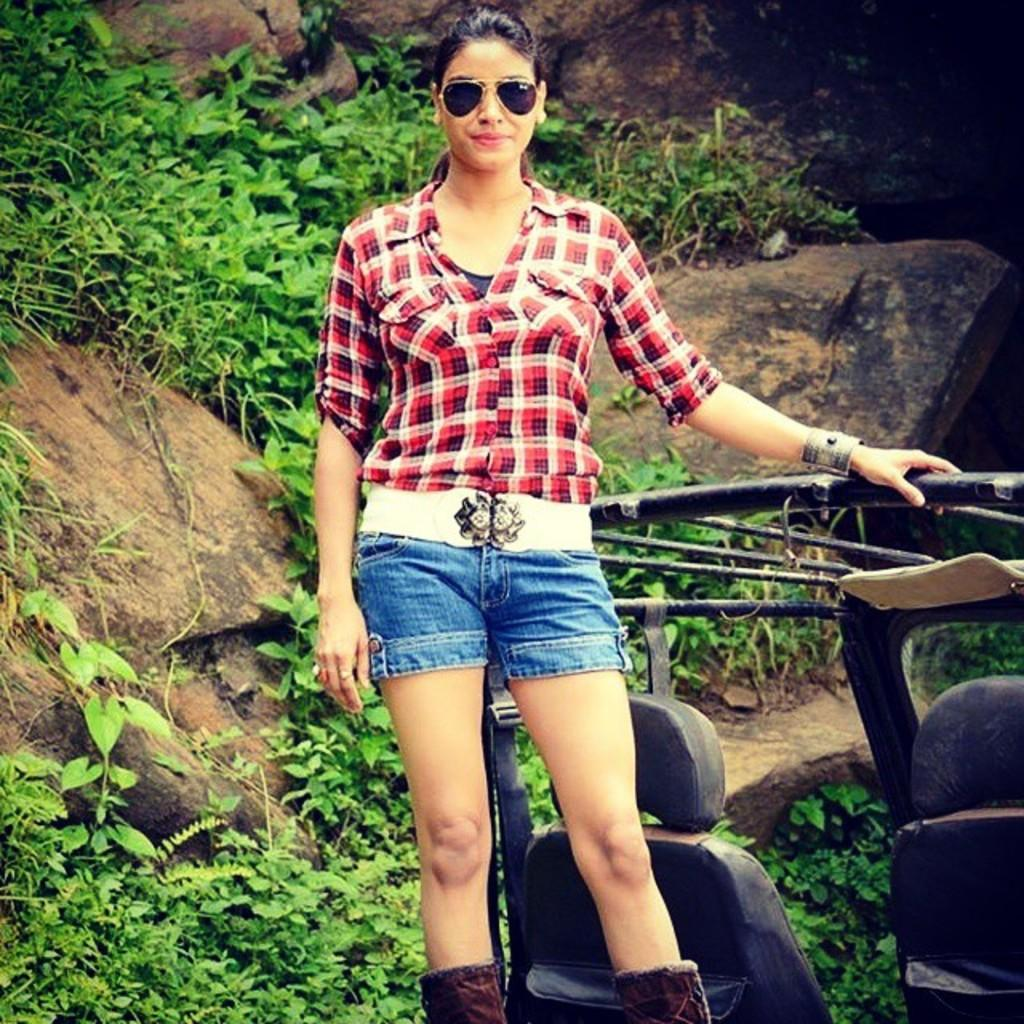Who is present in the image? There is a woman in the image. What is the woman doing in the image? The woman is standing on a vehicle. What protective gear is the woman wearing? The woman is wearing goggles. What clothing items is the woman wearing? The woman is wearing a red check shirt, blue shorts, and brown shoes. What can be seen in the background of the image? There are plants and rocks in the background of the image. What type of street can be seen in the image? There is no street visible in the image; it features a woman standing on a vehicle in a background with plants and rocks. 